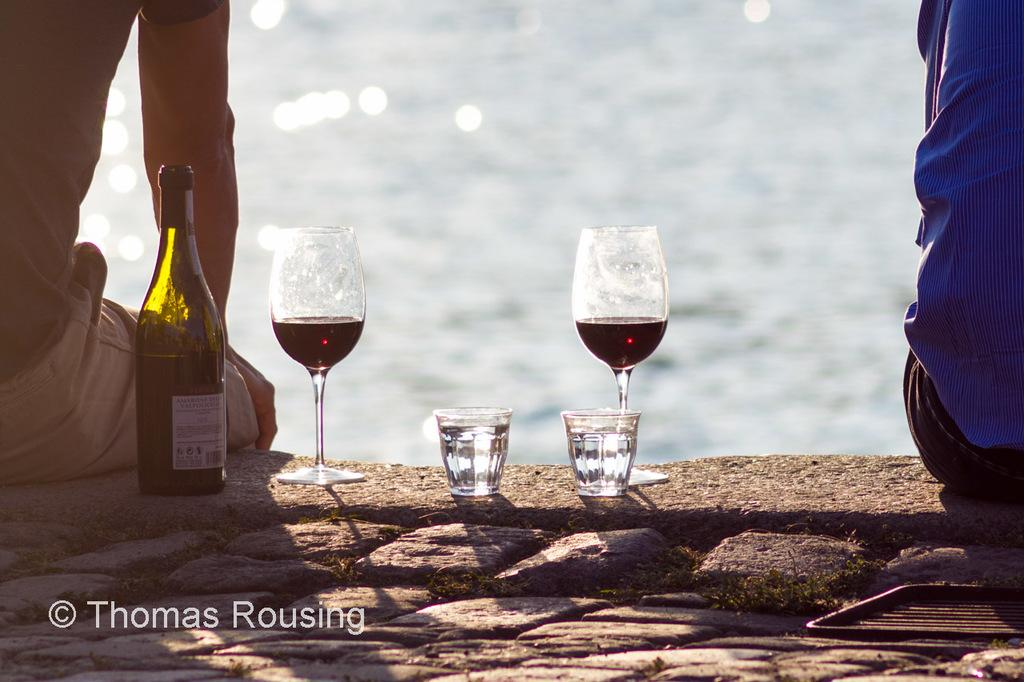What type of beverage is associated with the bottle in the image? There is a wine bottle in the image. What type of glassware is present in the image? There are wine glasses in the image. Where are the wine bottle and glasses located? The wine bottle and glasses are placed on the floor. How many people are present in the image? There are two persons sitting in the image. What can be seen in the background of the image? There is water visible in the background of the image. Are there any ants crawling on the wine bottle in the image? There is no mention of ants in the provided facts, so we cannot determine if there are any ants present in the image. What type of work does the laborer in the image perform? There is no laborer present in the image, as the facts only mention two persons sitting. 